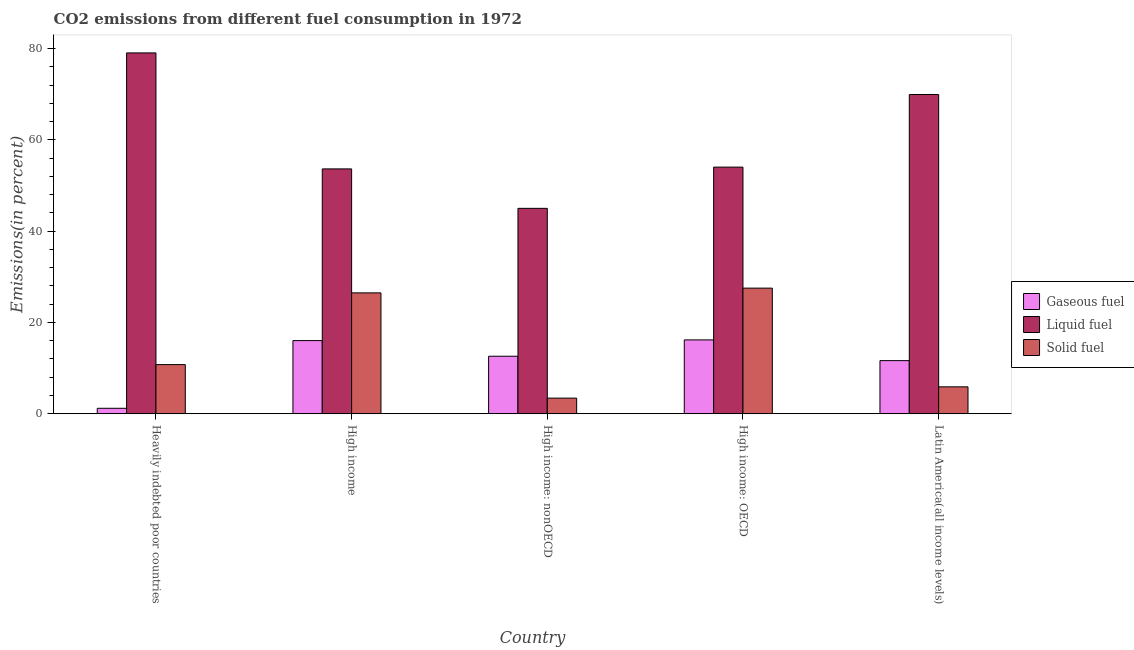How many different coloured bars are there?
Offer a very short reply. 3. How many bars are there on the 5th tick from the left?
Make the answer very short. 3. What is the label of the 5th group of bars from the left?
Your answer should be compact. Latin America(all income levels). In how many cases, is the number of bars for a given country not equal to the number of legend labels?
Keep it short and to the point. 0. What is the percentage of liquid fuel emission in High income: nonOECD?
Offer a very short reply. 45.01. Across all countries, what is the maximum percentage of liquid fuel emission?
Your answer should be very brief. 79.07. Across all countries, what is the minimum percentage of solid fuel emission?
Provide a succinct answer. 3.42. In which country was the percentage of solid fuel emission maximum?
Keep it short and to the point. High income: OECD. In which country was the percentage of liquid fuel emission minimum?
Provide a short and direct response. High income: nonOECD. What is the total percentage of liquid fuel emission in the graph?
Provide a short and direct response. 301.73. What is the difference between the percentage of liquid fuel emission in High income: OECD and that in Latin America(all income levels)?
Offer a terse response. -15.91. What is the difference between the percentage of gaseous fuel emission in Heavily indebted poor countries and the percentage of liquid fuel emission in High income?
Make the answer very short. -52.46. What is the average percentage of gaseous fuel emission per country?
Your response must be concise. 11.53. What is the difference between the percentage of solid fuel emission and percentage of gaseous fuel emission in Heavily indebted poor countries?
Your response must be concise. 9.57. In how many countries, is the percentage of gaseous fuel emission greater than 8 %?
Your response must be concise. 4. What is the ratio of the percentage of liquid fuel emission in High income: OECD to that in High income: nonOECD?
Ensure brevity in your answer.  1.2. Is the percentage of solid fuel emission in Heavily indebted poor countries less than that in High income: nonOECD?
Keep it short and to the point. No. Is the difference between the percentage of liquid fuel emission in Heavily indebted poor countries and High income: nonOECD greater than the difference between the percentage of solid fuel emission in Heavily indebted poor countries and High income: nonOECD?
Your response must be concise. Yes. What is the difference between the highest and the second highest percentage of liquid fuel emission?
Provide a succinct answer. 9.11. What is the difference between the highest and the lowest percentage of liquid fuel emission?
Offer a terse response. 34.06. In how many countries, is the percentage of gaseous fuel emission greater than the average percentage of gaseous fuel emission taken over all countries?
Provide a short and direct response. 4. What does the 3rd bar from the left in Heavily indebted poor countries represents?
Ensure brevity in your answer.  Solid fuel. What does the 3rd bar from the right in High income represents?
Offer a terse response. Gaseous fuel. Is it the case that in every country, the sum of the percentage of gaseous fuel emission and percentage of liquid fuel emission is greater than the percentage of solid fuel emission?
Make the answer very short. Yes. Are all the bars in the graph horizontal?
Ensure brevity in your answer.  No. Are the values on the major ticks of Y-axis written in scientific E-notation?
Your answer should be compact. No. Where does the legend appear in the graph?
Provide a short and direct response. Center right. What is the title of the graph?
Make the answer very short. CO2 emissions from different fuel consumption in 1972. Does "Taxes" appear as one of the legend labels in the graph?
Provide a succinct answer. No. What is the label or title of the X-axis?
Provide a short and direct response. Country. What is the label or title of the Y-axis?
Your answer should be compact. Emissions(in percent). What is the Emissions(in percent) in Gaseous fuel in Heavily indebted poor countries?
Your response must be concise. 1.2. What is the Emissions(in percent) in Liquid fuel in Heavily indebted poor countries?
Provide a succinct answer. 79.07. What is the Emissions(in percent) of Solid fuel in Heavily indebted poor countries?
Your response must be concise. 10.77. What is the Emissions(in percent) in Gaseous fuel in High income?
Keep it short and to the point. 16.03. What is the Emissions(in percent) in Liquid fuel in High income?
Your answer should be compact. 53.65. What is the Emissions(in percent) in Solid fuel in High income?
Offer a terse response. 26.48. What is the Emissions(in percent) of Gaseous fuel in High income: nonOECD?
Keep it short and to the point. 12.6. What is the Emissions(in percent) in Liquid fuel in High income: nonOECD?
Provide a succinct answer. 45.01. What is the Emissions(in percent) of Solid fuel in High income: nonOECD?
Make the answer very short. 3.42. What is the Emissions(in percent) in Gaseous fuel in High income: OECD?
Your response must be concise. 16.18. What is the Emissions(in percent) in Liquid fuel in High income: OECD?
Your answer should be compact. 54.04. What is the Emissions(in percent) in Solid fuel in High income: OECD?
Your answer should be compact. 27.52. What is the Emissions(in percent) of Gaseous fuel in Latin America(all income levels)?
Provide a short and direct response. 11.64. What is the Emissions(in percent) of Liquid fuel in Latin America(all income levels)?
Offer a terse response. 69.96. What is the Emissions(in percent) of Solid fuel in Latin America(all income levels)?
Ensure brevity in your answer.  5.9. Across all countries, what is the maximum Emissions(in percent) of Gaseous fuel?
Your answer should be very brief. 16.18. Across all countries, what is the maximum Emissions(in percent) of Liquid fuel?
Keep it short and to the point. 79.07. Across all countries, what is the maximum Emissions(in percent) in Solid fuel?
Your answer should be compact. 27.52. Across all countries, what is the minimum Emissions(in percent) of Gaseous fuel?
Offer a very short reply. 1.2. Across all countries, what is the minimum Emissions(in percent) in Liquid fuel?
Your response must be concise. 45.01. Across all countries, what is the minimum Emissions(in percent) of Solid fuel?
Offer a terse response. 3.42. What is the total Emissions(in percent) in Gaseous fuel in the graph?
Give a very brief answer. 57.64. What is the total Emissions(in percent) of Liquid fuel in the graph?
Your answer should be compact. 301.73. What is the total Emissions(in percent) of Solid fuel in the graph?
Provide a succinct answer. 74.09. What is the difference between the Emissions(in percent) of Gaseous fuel in Heavily indebted poor countries and that in High income?
Your answer should be very brief. -14.83. What is the difference between the Emissions(in percent) of Liquid fuel in Heavily indebted poor countries and that in High income?
Your answer should be very brief. 25.41. What is the difference between the Emissions(in percent) of Solid fuel in Heavily indebted poor countries and that in High income?
Offer a terse response. -15.72. What is the difference between the Emissions(in percent) of Gaseous fuel in Heavily indebted poor countries and that in High income: nonOECD?
Your answer should be very brief. -11.41. What is the difference between the Emissions(in percent) of Liquid fuel in Heavily indebted poor countries and that in High income: nonOECD?
Offer a very short reply. 34.06. What is the difference between the Emissions(in percent) of Solid fuel in Heavily indebted poor countries and that in High income: nonOECD?
Your answer should be very brief. 7.34. What is the difference between the Emissions(in percent) in Gaseous fuel in Heavily indebted poor countries and that in High income: OECD?
Make the answer very short. -14.99. What is the difference between the Emissions(in percent) of Liquid fuel in Heavily indebted poor countries and that in High income: OECD?
Your answer should be compact. 25.02. What is the difference between the Emissions(in percent) of Solid fuel in Heavily indebted poor countries and that in High income: OECD?
Your response must be concise. -16.76. What is the difference between the Emissions(in percent) in Gaseous fuel in Heavily indebted poor countries and that in Latin America(all income levels)?
Your response must be concise. -10.44. What is the difference between the Emissions(in percent) of Liquid fuel in Heavily indebted poor countries and that in Latin America(all income levels)?
Offer a very short reply. 9.11. What is the difference between the Emissions(in percent) in Solid fuel in Heavily indebted poor countries and that in Latin America(all income levels)?
Keep it short and to the point. 4.87. What is the difference between the Emissions(in percent) in Gaseous fuel in High income and that in High income: nonOECD?
Your answer should be compact. 3.42. What is the difference between the Emissions(in percent) in Liquid fuel in High income and that in High income: nonOECD?
Offer a terse response. 8.65. What is the difference between the Emissions(in percent) in Solid fuel in High income and that in High income: nonOECD?
Your answer should be compact. 23.06. What is the difference between the Emissions(in percent) in Gaseous fuel in High income and that in High income: OECD?
Your answer should be compact. -0.15. What is the difference between the Emissions(in percent) in Liquid fuel in High income and that in High income: OECD?
Provide a succinct answer. -0.39. What is the difference between the Emissions(in percent) in Solid fuel in High income and that in High income: OECD?
Offer a terse response. -1.04. What is the difference between the Emissions(in percent) in Gaseous fuel in High income and that in Latin America(all income levels)?
Ensure brevity in your answer.  4.39. What is the difference between the Emissions(in percent) of Liquid fuel in High income and that in Latin America(all income levels)?
Make the answer very short. -16.3. What is the difference between the Emissions(in percent) of Solid fuel in High income and that in Latin America(all income levels)?
Make the answer very short. 20.59. What is the difference between the Emissions(in percent) in Gaseous fuel in High income: nonOECD and that in High income: OECD?
Make the answer very short. -3.58. What is the difference between the Emissions(in percent) in Liquid fuel in High income: nonOECD and that in High income: OECD?
Make the answer very short. -9.04. What is the difference between the Emissions(in percent) in Solid fuel in High income: nonOECD and that in High income: OECD?
Provide a succinct answer. -24.1. What is the difference between the Emissions(in percent) in Gaseous fuel in High income: nonOECD and that in Latin America(all income levels)?
Your answer should be very brief. 0.97. What is the difference between the Emissions(in percent) in Liquid fuel in High income: nonOECD and that in Latin America(all income levels)?
Provide a succinct answer. -24.95. What is the difference between the Emissions(in percent) in Solid fuel in High income: nonOECD and that in Latin America(all income levels)?
Your answer should be very brief. -2.47. What is the difference between the Emissions(in percent) of Gaseous fuel in High income: OECD and that in Latin America(all income levels)?
Make the answer very short. 4.54. What is the difference between the Emissions(in percent) in Liquid fuel in High income: OECD and that in Latin America(all income levels)?
Give a very brief answer. -15.91. What is the difference between the Emissions(in percent) of Solid fuel in High income: OECD and that in Latin America(all income levels)?
Your answer should be compact. 21.63. What is the difference between the Emissions(in percent) of Gaseous fuel in Heavily indebted poor countries and the Emissions(in percent) of Liquid fuel in High income?
Provide a succinct answer. -52.46. What is the difference between the Emissions(in percent) in Gaseous fuel in Heavily indebted poor countries and the Emissions(in percent) in Solid fuel in High income?
Give a very brief answer. -25.29. What is the difference between the Emissions(in percent) of Liquid fuel in Heavily indebted poor countries and the Emissions(in percent) of Solid fuel in High income?
Your answer should be very brief. 52.58. What is the difference between the Emissions(in percent) in Gaseous fuel in Heavily indebted poor countries and the Emissions(in percent) in Liquid fuel in High income: nonOECD?
Provide a succinct answer. -43.81. What is the difference between the Emissions(in percent) of Gaseous fuel in Heavily indebted poor countries and the Emissions(in percent) of Solid fuel in High income: nonOECD?
Your response must be concise. -2.23. What is the difference between the Emissions(in percent) of Liquid fuel in Heavily indebted poor countries and the Emissions(in percent) of Solid fuel in High income: nonOECD?
Make the answer very short. 75.64. What is the difference between the Emissions(in percent) in Gaseous fuel in Heavily indebted poor countries and the Emissions(in percent) in Liquid fuel in High income: OECD?
Your answer should be compact. -52.85. What is the difference between the Emissions(in percent) of Gaseous fuel in Heavily indebted poor countries and the Emissions(in percent) of Solid fuel in High income: OECD?
Make the answer very short. -26.33. What is the difference between the Emissions(in percent) in Liquid fuel in Heavily indebted poor countries and the Emissions(in percent) in Solid fuel in High income: OECD?
Ensure brevity in your answer.  51.54. What is the difference between the Emissions(in percent) of Gaseous fuel in Heavily indebted poor countries and the Emissions(in percent) of Liquid fuel in Latin America(all income levels)?
Offer a terse response. -68.76. What is the difference between the Emissions(in percent) in Gaseous fuel in Heavily indebted poor countries and the Emissions(in percent) in Solid fuel in Latin America(all income levels)?
Offer a very short reply. -4.7. What is the difference between the Emissions(in percent) of Liquid fuel in Heavily indebted poor countries and the Emissions(in percent) of Solid fuel in Latin America(all income levels)?
Give a very brief answer. 73.17. What is the difference between the Emissions(in percent) of Gaseous fuel in High income and the Emissions(in percent) of Liquid fuel in High income: nonOECD?
Offer a terse response. -28.98. What is the difference between the Emissions(in percent) in Gaseous fuel in High income and the Emissions(in percent) in Solid fuel in High income: nonOECD?
Provide a short and direct response. 12.6. What is the difference between the Emissions(in percent) of Liquid fuel in High income and the Emissions(in percent) of Solid fuel in High income: nonOECD?
Your response must be concise. 50.23. What is the difference between the Emissions(in percent) of Gaseous fuel in High income and the Emissions(in percent) of Liquid fuel in High income: OECD?
Provide a succinct answer. -38.02. What is the difference between the Emissions(in percent) of Gaseous fuel in High income and the Emissions(in percent) of Solid fuel in High income: OECD?
Ensure brevity in your answer.  -11.5. What is the difference between the Emissions(in percent) of Liquid fuel in High income and the Emissions(in percent) of Solid fuel in High income: OECD?
Provide a succinct answer. 26.13. What is the difference between the Emissions(in percent) in Gaseous fuel in High income and the Emissions(in percent) in Liquid fuel in Latin America(all income levels)?
Offer a very short reply. -53.93. What is the difference between the Emissions(in percent) of Gaseous fuel in High income and the Emissions(in percent) of Solid fuel in Latin America(all income levels)?
Provide a short and direct response. 10.13. What is the difference between the Emissions(in percent) of Liquid fuel in High income and the Emissions(in percent) of Solid fuel in Latin America(all income levels)?
Provide a short and direct response. 47.76. What is the difference between the Emissions(in percent) of Gaseous fuel in High income: nonOECD and the Emissions(in percent) of Liquid fuel in High income: OECD?
Your response must be concise. -41.44. What is the difference between the Emissions(in percent) of Gaseous fuel in High income: nonOECD and the Emissions(in percent) of Solid fuel in High income: OECD?
Provide a succinct answer. -14.92. What is the difference between the Emissions(in percent) of Liquid fuel in High income: nonOECD and the Emissions(in percent) of Solid fuel in High income: OECD?
Give a very brief answer. 17.48. What is the difference between the Emissions(in percent) in Gaseous fuel in High income: nonOECD and the Emissions(in percent) in Liquid fuel in Latin America(all income levels)?
Provide a short and direct response. -57.35. What is the difference between the Emissions(in percent) of Gaseous fuel in High income: nonOECD and the Emissions(in percent) of Solid fuel in Latin America(all income levels)?
Ensure brevity in your answer.  6.71. What is the difference between the Emissions(in percent) of Liquid fuel in High income: nonOECD and the Emissions(in percent) of Solid fuel in Latin America(all income levels)?
Provide a succinct answer. 39.11. What is the difference between the Emissions(in percent) of Gaseous fuel in High income: OECD and the Emissions(in percent) of Liquid fuel in Latin America(all income levels)?
Offer a terse response. -53.78. What is the difference between the Emissions(in percent) of Gaseous fuel in High income: OECD and the Emissions(in percent) of Solid fuel in Latin America(all income levels)?
Provide a succinct answer. 10.29. What is the difference between the Emissions(in percent) of Liquid fuel in High income: OECD and the Emissions(in percent) of Solid fuel in Latin America(all income levels)?
Give a very brief answer. 48.15. What is the average Emissions(in percent) in Gaseous fuel per country?
Give a very brief answer. 11.53. What is the average Emissions(in percent) in Liquid fuel per country?
Offer a terse response. 60.35. What is the average Emissions(in percent) of Solid fuel per country?
Your answer should be very brief. 14.82. What is the difference between the Emissions(in percent) in Gaseous fuel and Emissions(in percent) in Liquid fuel in Heavily indebted poor countries?
Your answer should be very brief. -77.87. What is the difference between the Emissions(in percent) of Gaseous fuel and Emissions(in percent) of Solid fuel in Heavily indebted poor countries?
Keep it short and to the point. -9.57. What is the difference between the Emissions(in percent) in Liquid fuel and Emissions(in percent) in Solid fuel in Heavily indebted poor countries?
Your response must be concise. 68.3. What is the difference between the Emissions(in percent) in Gaseous fuel and Emissions(in percent) in Liquid fuel in High income?
Give a very brief answer. -37.63. What is the difference between the Emissions(in percent) of Gaseous fuel and Emissions(in percent) of Solid fuel in High income?
Your answer should be very brief. -10.46. What is the difference between the Emissions(in percent) of Liquid fuel and Emissions(in percent) of Solid fuel in High income?
Your answer should be very brief. 27.17. What is the difference between the Emissions(in percent) of Gaseous fuel and Emissions(in percent) of Liquid fuel in High income: nonOECD?
Give a very brief answer. -32.4. What is the difference between the Emissions(in percent) of Gaseous fuel and Emissions(in percent) of Solid fuel in High income: nonOECD?
Your answer should be compact. 9.18. What is the difference between the Emissions(in percent) of Liquid fuel and Emissions(in percent) of Solid fuel in High income: nonOECD?
Provide a short and direct response. 41.58. What is the difference between the Emissions(in percent) of Gaseous fuel and Emissions(in percent) of Liquid fuel in High income: OECD?
Offer a terse response. -37.86. What is the difference between the Emissions(in percent) in Gaseous fuel and Emissions(in percent) in Solid fuel in High income: OECD?
Your answer should be very brief. -11.34. What is the difference between the Emissions(in percent) in Liquid fuel and Emissions(in percent) in Solid fuel in High income: OECD?
Your response must be concise. 26.52. What is the difference between the Emissions(in percent) of Gaseous fuel and Emissions(in percent) of Liquid fuel in Latin America(all income levels)?
Your answer should be very brief. -58.32. What is the difference between the Emissions(in percent) in Gaseous fuel and Emissions(in percent) in Solid fuel in Latin America(all income levels)?
Offer a very short reply. 5.74. What is the difference between the Emissions(in percent) in Liquid fuel and Emissions(in percent) in Solid fuel in Latin America(all income levels)?
Your response must be concise. 64.06. What is the ratio of the Emissions(in percent) of Gaseous fuel in Heavily indebted poor countries to that in High income?
Make the answer very short. 0.07. What is the ratio of the Emissions(in percent) of Liquid fuel in Heavily indebted poor countries to that in High income?
Keep it short and to the point. 1.47. What is the ratio of the Emissions(in percent) of Solid fuel in Heavily indebted poor countries to that in High income?
Your answer should be compact. 0.41. What is the ratio of the Emissions(in percent) in Gaseous fuel in Heavily indebted poor countries to that in High income: nonOECD?
Ensure brevity in your answer.  0.09. What is the ratio of the Emissions(in percent) of Liquid fuel in Heavily indebted poor countries to that in High income: nonOECD?
Provide a short and direct response. 1.76. What is the ratio of the Emissions(in percent) of Solid fuel in Heavily indebted poor countries to that in High income: nonOECD?
Your response must be concise. 3.15. What is the ratio of the Emissions(in percent) in Gaseous fuel in Heavily indebted poor countries to that in High income: OECD?
Your answer should be very brief. 0.07. What is the ratio of the Emissions(in percent) in Liquid fuel in Heavily indebted poor countries to that in High income: OECD?
Your response must be concise. 1.46. What is the ratio of the Emissions(in percent) of Solid fuel in Heavily indebted poor countries to that in High income: OECD?
Your answer should be very brief. 0.39. What is the ratio of the Emissions(in percent) of Gaseous fuel in Heavily indebted poor countries to that in Latin America(all income levels)?
Provide a succinct answer. 0.1. What is the ratio of the Emissions(in percent) in Liquid fuel in Heavily indebted poor countries to that in Latin America(all income levels)?
Ensure brevity in your answer.  1.13. What is the ratio of the Emissions(in percent) in Solid fuel in Heavily indebted poor countries to that in Latin America(all income levels)?
Ensure brevity in your answer.  1.83. What is the ratio of the Emissions(in percent) of Gaseous fuel in High income to that in High income: nonOECD?
Your answer should be very brief. 1.27. What is the ratio of the Emissions(in percent) in Liquid fuel in High income to that in High income: nonOECD?
Ensure brevity in your answer.  1.19. What is the ratio of the Emissions(in percent) in Solid fuel in High income to that in High income: nonOECD?
Provide a short and direct response. 7.74. What is the ratio of the Emissions(in percent) of Gaseous fuel in High income to that in High income: OECD?
Your answer should be very brief. 0.99. What is the ratio of the Emissions(in percent) of Solid fuel in High income to that in High income: OECD?
Offer a very short reply. 0.96. What is the ratio of the Emissions(in percent) of Gaseous fuel in High income to that in Latin America(all income levels)?
Give a very brief answer. 1.38. What is the ratio of the Emissions(in percent) in Liquid fuel in High income to that in Latin America(all income levels)?
Give a very brief answer. 0.77. What is the ratio of the Emissions(in percent) of Solid fuel in High income to that in Latin America(all income levels)?
Your answer should be very brief. 4.49. What is the ratio of the Emissions(in percent) in Gaseous fuel in High income: nonOECD to that in High income: OECD?
Offer a terse response. 0.78. What is the ratio of the Emissions(in percent) in Liquid fuel in High income: nonOECD to that in High income: OECD?
Give a very brief answer. 0.83. What is the ratio of the Emissions(in percent) of Solid fuel in High income: nonOECD to that in High income: OECD?
Keep it short and to the point. 0.12. What is the ratio of the Emissions(in percent) in Gaseous fuel in High income: nonOECD to that in Latin America(all income levels)?
Provide a succinct answer. 1.08. What is the ratio of the Emissions(in percent) of Liquid fuel in High income: nonOECD to that in Latin America(all income levels)?
Your response must be concise. 0.64. What is the ratio of the Emissions(in percent) of Solid fuel in High income: nonOECD to that in Latin America(all income levels)?
Offer a terse response. 0.58. What is the ratio of the Emissions(in percent) in Gaseous fuel in High income: OECD to that in Latin America(all income levels)?
Give a very brief answer. 1.39. What is the ratio of the Emissions(in percent) of Liquid fuel in High income: OECD to that in Latin America(all income levels)?
Keep it short and to the point. 0.77. What is the ratio of the Emissions(in percent) in Solid fuel in High income: OECD to that in Latin America(all income levels)?
Your answer should be very brief. 4.67. What is the difference between the highest and the second highest Emissions(in percent) in Gaseous fuel?
Offer a very short reply. 0.15. What is the difference between the highest and the second highest Emissions(in percent) of Liquid fuel?
Make the answer very short. 9.11. What is the difference between the highest and the second highest Emissions(in percent) of Solid fuel?
Provide a short and direct response. 1.04. What is the difference between the highest and the lowest Emissions(in percent) in Gaseous fuel?
Your answer should be very brief. 14.99. What is the difference between the highest and the lowest Emissions(in percent) of Liquid fuel?
Provide a succinct answer. 34.06. What is the difference between the highest and the lowest Emissions(in percent) in Solid fuel?
Offer a very short reply. 24.1. 